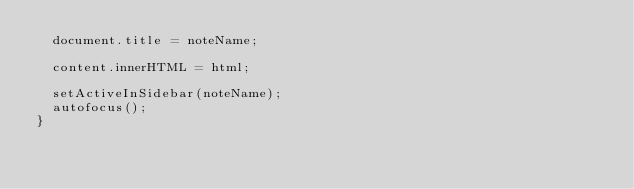Convert code to text. <code><loc_0><loc_0><loc_500><loc_500><_TypeScript_>  document.title = noteName;

  content.innerHTML = html;

  setActiveInSidebar(noteName);
  autofocus();
}
</code> 